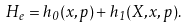Convert formula to latex. <formula><loc_0><loc_0><loc_500><loc_500>H _ { e } = h _ { 0 } ( x , p ) + h _ { 1 } ( X , x , p ) .</formula> 